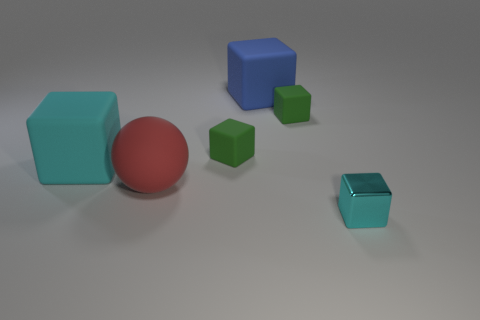Subtract all blue cubes. How many cubes are left? 4 Subtract all big blue rubber cubes. How many cubes are left? 4 Add 4 big blue rubber cylinders. How many objects exist? 10 Subtract all yellow blocks. Subtract all cyan cylinders. How many blocks are left? 5 Subtract all cubes. How many objects are left? 1 Add 2 tiny matte blocks. How many tiny matte blocks exist? 4 Subtract 0 brown blocks. How many objects are left? 6 Subtract all tiny brown metallic cubes. Subtract all shiny blocks. How many objects are left? 5 Add 5 large matte objects. How many large matte objects are left? 8 